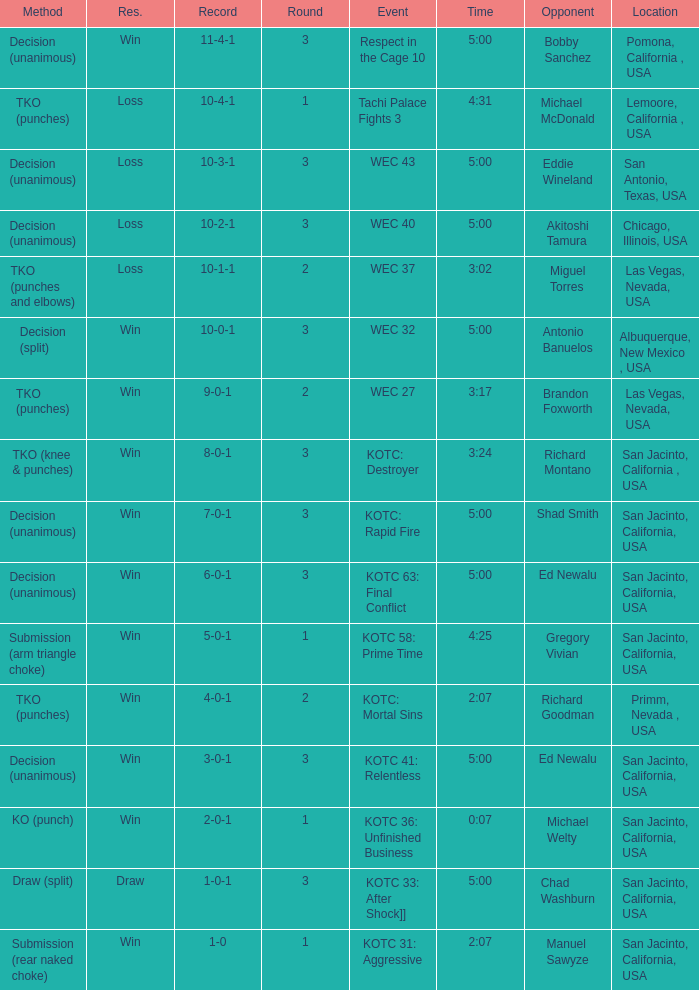What time did the even tachi palace fights 3 take place? 4:31. 